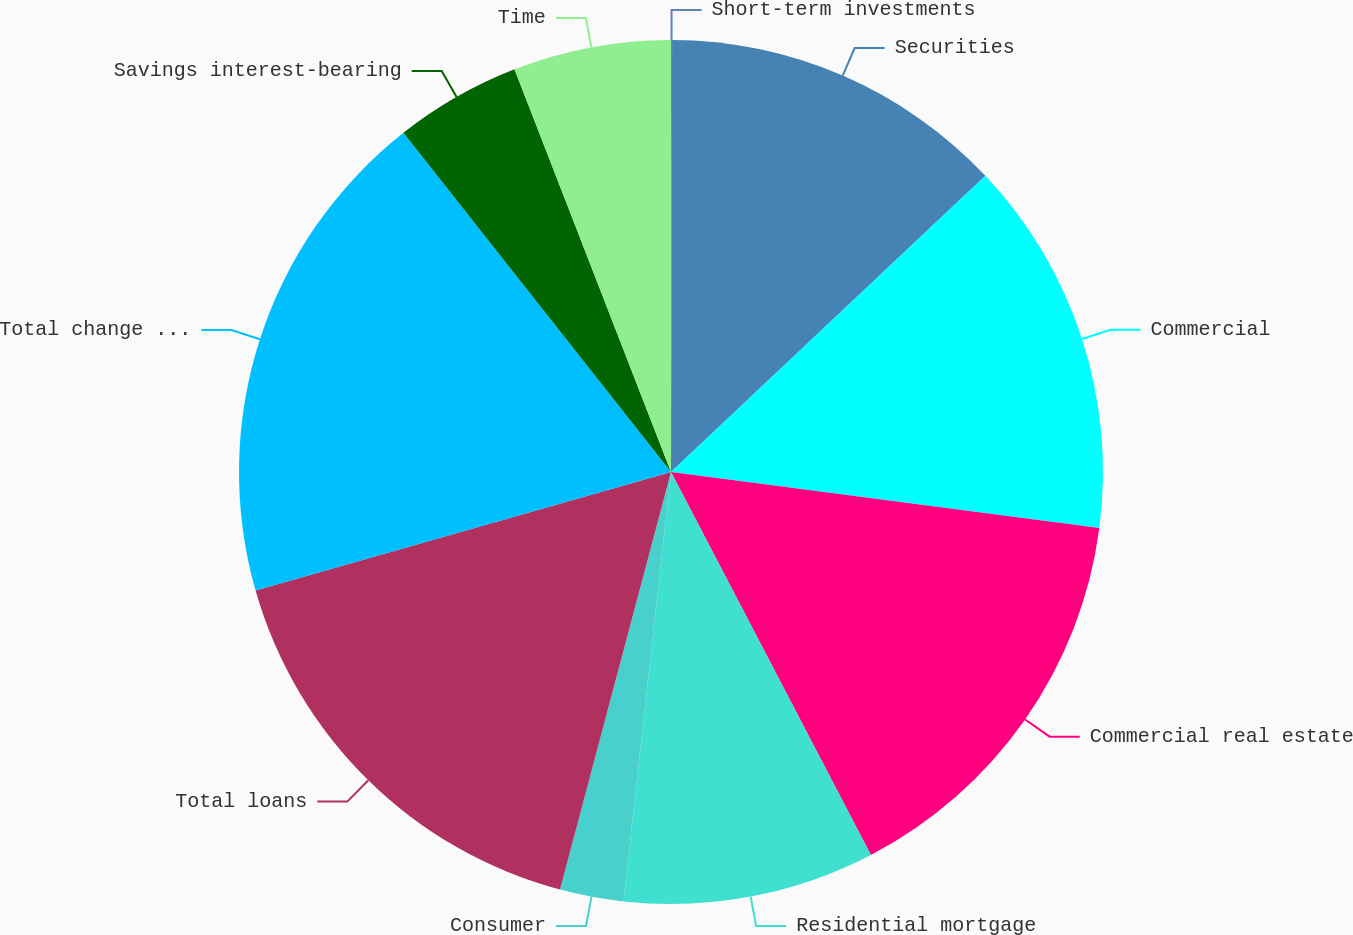<chart> <loc_0><loc_0><loc_500><loc_500><pie_chart><fcel>Short-term investments<fcel>Securities<fcel>Commercial<fcel>Commercial real estate<fcel>Residential mortgage<fcel>Consumer<fcel>Total loans<fcel>Total change in interest and<fcel>Savings interest-bearing<fcel>Time<nl><fcel>0.04%<fcel>12.93%<fcel>14.1%<fcel>15.27%<fcel>9.41%<fcel>2.38%<fcel>16.44%<fcel>18.79%<fcel>4.73%<fcel>5.9%<nl></chart> 